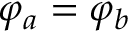<formula> <loc_0><loc_0><loc_500><loc_500>\varphi _ { a } = \varphi _ { b }</formula> 